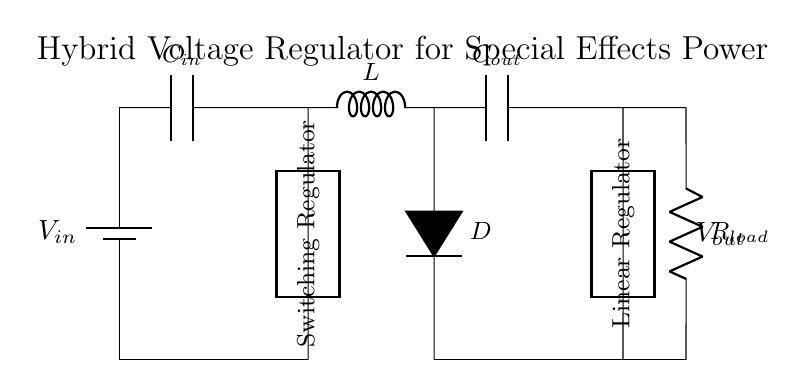What powers the circuit? The circuit is powered by the battery labeled V_in, which provides the input voltage necessary for operation.
Answer: Battery What type of regulator is used for output voltage stabilization? The circuit features both a switching regulator followed by a linear regulator; this combination stabilizes the output voltage through different methods.
Answer: Switching and Linear What is the role of C_in in this circuit? The input capacitor, labeled C_in, filters and stabilizes the input voltage from the power supply to prevent voltage spikes and ensure smooth operation.
Answer: Input filtering How many capacitors are in the circuit? There are two capacitors present in the circuit: one input capacitor and one output capacitor for filtering purposes.
Answer: Two What component converts DC voltage to a lower DC voltage? The linear regulator is specifically designed to convert a higher DC voltage to a lower, regulated DC output voltage suitable for static load requirements.
Answer: Linear Regulator What is the purpose of the diode in this circuit? The diode, labeled D, prevents backflow of current from the output to the input side during the switching process, ensuring unidirectional flow and protection for the circuit.
Answer: Current protection How does the inductor function in this hybrid design? The inductor temporarily stores energy when the switching regulator is active and releases it to smooth out fluctuations in current, aiding in voltage regulation during load changes.
Answer: Energy storage 